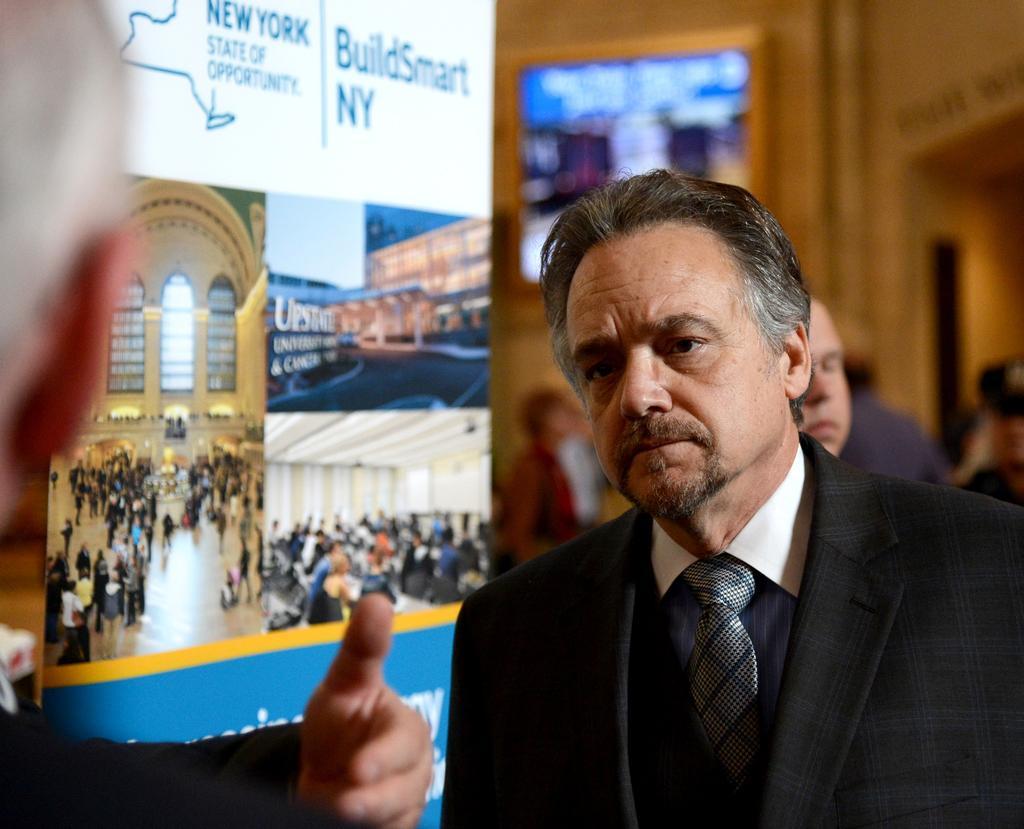In one or two sentences, can you explain what this image depicts? In this image we can see some people. We can also see a board with some pictures and text on it. On the backside we can see a group of people and a frame on a wall. 